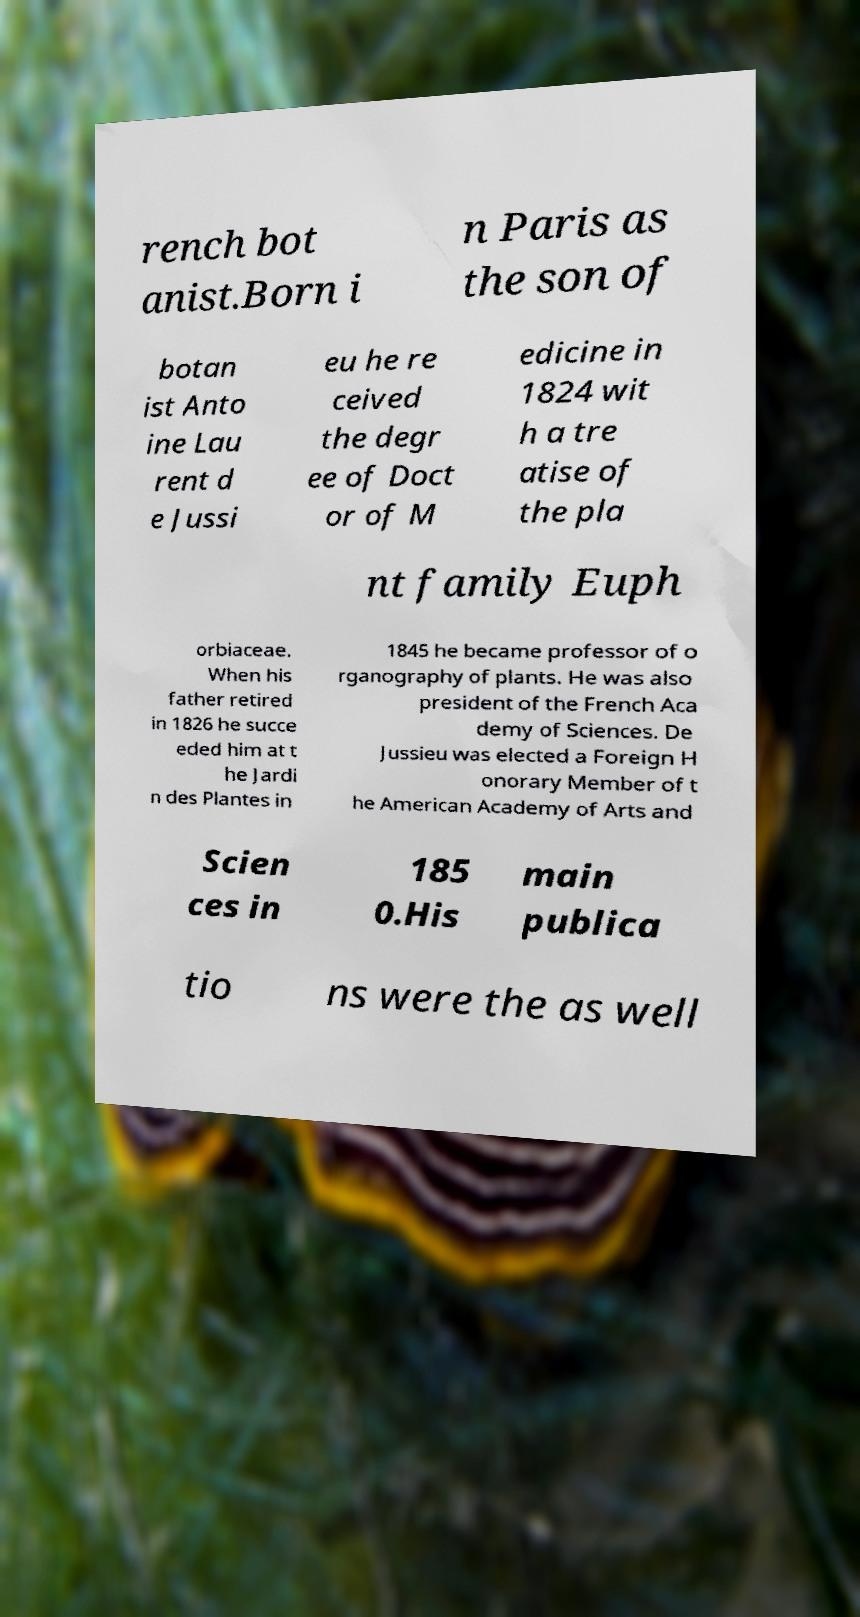For documentation purposes, I need the text within this image transcribed. Could you provide that? rench bot anist.Born i n Paris as the son of botan ist Anto ine Lau rent d e Jussi eu he re ceived the degr ee of Doct or of M edicine in 1824 wit h a tre atise of the pla nt family Euph orbiaceae. When his father retired in 1826 he succe eded him at t he Jardi n des Plantes in 1845 he became professor of o rganography of plants. He was also president of the French Aca demy of Sciences. De Jussieu was elected a Foreign H onorary Member of t he American Academy of Arts and Scien ces in 185 0.His main publica tio ns were the as well 